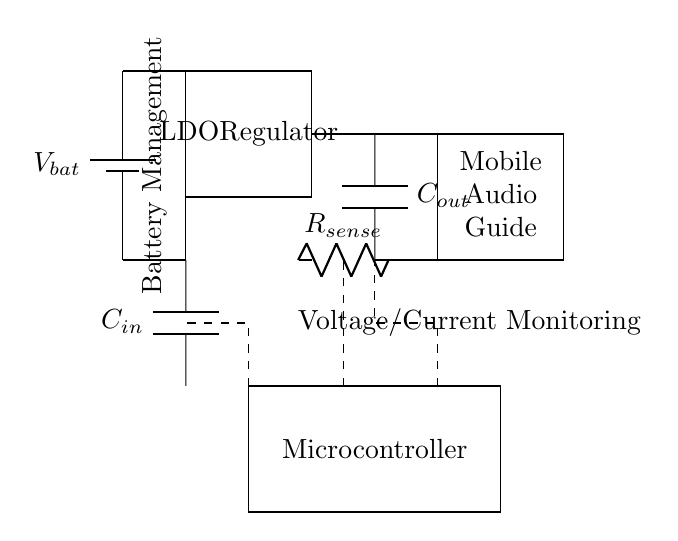What is the main purpose of the LDO regulator in this circuit? The LDO regulator's main purpose is to provide a stable voltage output from the battery supply to ensure that the mobile audio guide operates correctly without fluctuations.
Answer: Stable voltage output What component is used for input filtering? The component used for input filtering is the capacitor labeled C in, which is positioned before the LDO regulator. This helps smooth any variations in the input voltage.
Answer: Capacitor What is the role of the microcontroller in this circuit? The microcontroller's role is to monitor voltage and current levels, processing the information received from the sense resistor and ensuring optimal performance of the audio guide.
Answer: Monitoring How do the capacitors C in and C out differ in this circuit? Capacitor C in is used for input stability, filtering the input supply to the LDO, while C out ensures the output voltage remains stable by providing charge storage.
Answer: Different roles What does R sense measure in this circuit? R sense measures the current flowing to the mobile audio guide, allowing for monitoring of power consumption and overall system performance.
Answer: Current flow What type of circuit is represented by this diagram? The circuit type represented is a battery management system, primarily featuring a linear regulator configuration for managing voltage to connected loads.
Answer: Battery management system How is the audio guide powered? The audio guide is powered through the output of the LDO regulator, receiving stable voltage after the battery goes through the regulation process.
Answer: Through LDO output 